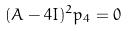Convert formula to latex. <formula><loc_0><loc_0><loc_500><loc_500>( A - 4 I ) ^ { 2 } p _ { 4 } = 0</formula> 